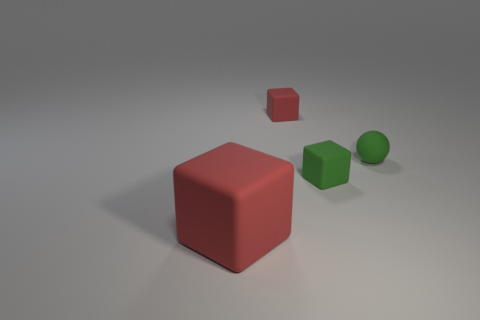Subtract all red blocks. How many blocks are left? 1 Subtract all red blocks. How many blocks are left? 1 Add 1 big rubber balls. How many objects exist? 5 Add 3 red rubber blocks. How many red rubber blocks are left? 5 Add 3 big yellow blocks. How many big yellow blocks exist? 3 Subtract 0 yellow blocks. How many objects are left? 4 Subtract all spheres. How many objects are left? 3 Subtract 3 blocks. How many blocks are left? 0 Subtract all red balls. Subtract all purple blocks. How many balls are left? 1 Subtract all cyan cylinders. How many brown spheres are left? 0 